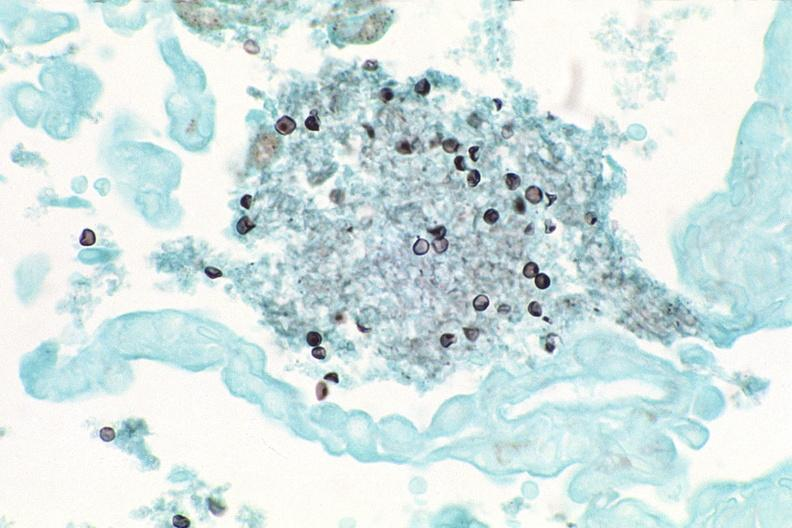do malignant adenoma stain?
Answer the question using a single word or phrase. No 